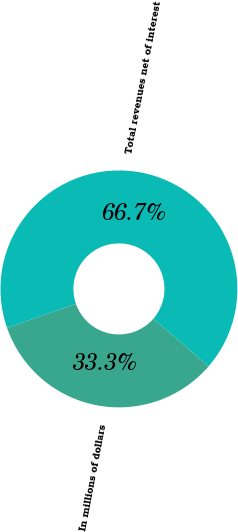Convert chart. <chart><loc_0><loc_0><loc_500><loc_500><pie_chart><fcel>In millions of dollars<fcel>Total revenues net of interest<nl><fcel>33.33%<fcel>66.67%<nl></chart> 